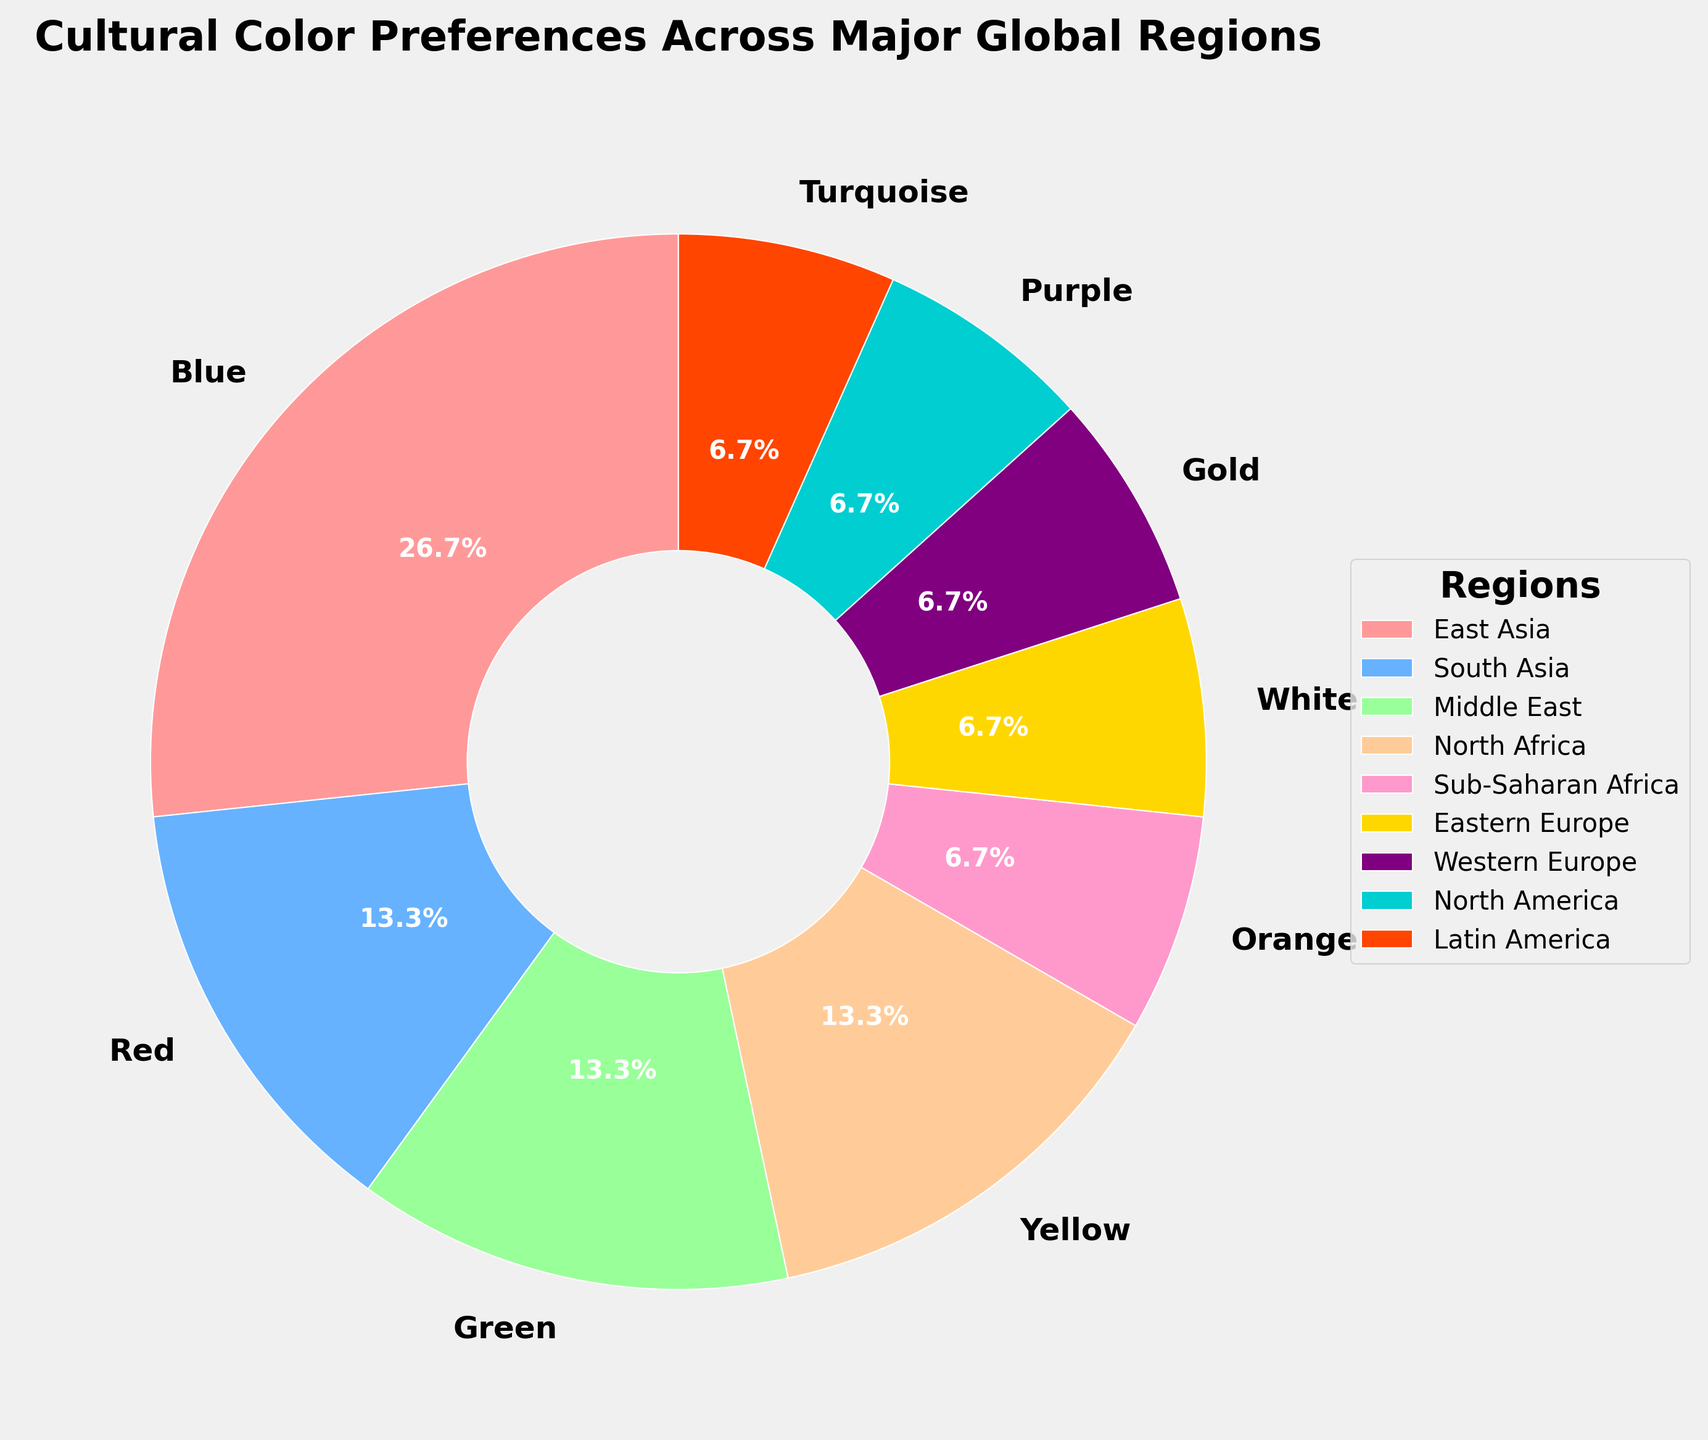What color is most preferred by regions in the figure? Inspect the size of the wedges in the pie chart to determine which color has the largest representation. Blue is the most dominant color with three regions preferring it.
Answer: Blue Which regions prefer Blue as their dominant color? Refer to the legend beside the pie chart to identify the regions associated with the Blue wedge in the pie chart. The regions are North America, Nordic Countries, and Mediterranean.
Answer: North America, Nordic Countries, Mediterranean How many different colors are represented in the figure? Count the number of unique colors shown in the pie chart.
Answer: Fifteen Which region prefers Green, and how significant is its preference compared to Yellow? Identify the Green and Yellow segments in the pie chart and refer to the legend. The Middle East and the Caribbean prefer Green, while Latin America and Southeast Asia prefer Yellow. Compare the sizes of these segments. Green and Yellow segments each represent two regions, making their significance equal.
Answer: Middle East, Caribbean; same as Yellow What percentage of regions prefer Red? Locate the Red segments in the pie chart. The regions are East Asia and Central Asia. Calculate the percentage by dividing the number of regions that prefer Red by the total number of regions. There are 15 regions in total, so the percentage is (2/15) * 100 = 13.3%.
Answer: 13.3% What is the dominant color preference in East Asia? Locate East Asia in the legend and note the color associated with it.
Answer: Red Which color is preferred by regions that are not contiguous, and what are these regions? Determine regions with the same color preference that are geographically separated. Blue is preferred by North America, Nordic Countries, and Mediterranean, which are not contiguous.
Answer: Blue; North America, Nordic Countries, Mediterranean Of the regions that prefer Green, which one is not contiguous with any regions that prefer Yellow, and what are these regions? Identify Green and Yellow preferences. Middle East and Caribbean prefer Green while Latin America and Southeast Asia prefer Yellow. Caribbean is not contiguous with any regions that prefer Yellow.
Answer: Caribbean Between Orange and Purple, which color has a higher percentage of preference, and what is that percentage? Compare the Orange and Purple segments in the pie chart in terms of size. Orange is preferred by South Asia and Purple by Western Europe. Each color is preferred by one region, so both have equal preference. Each has (1/15) * 100 = 6.7%.
Answer: Equal; 6.7% 